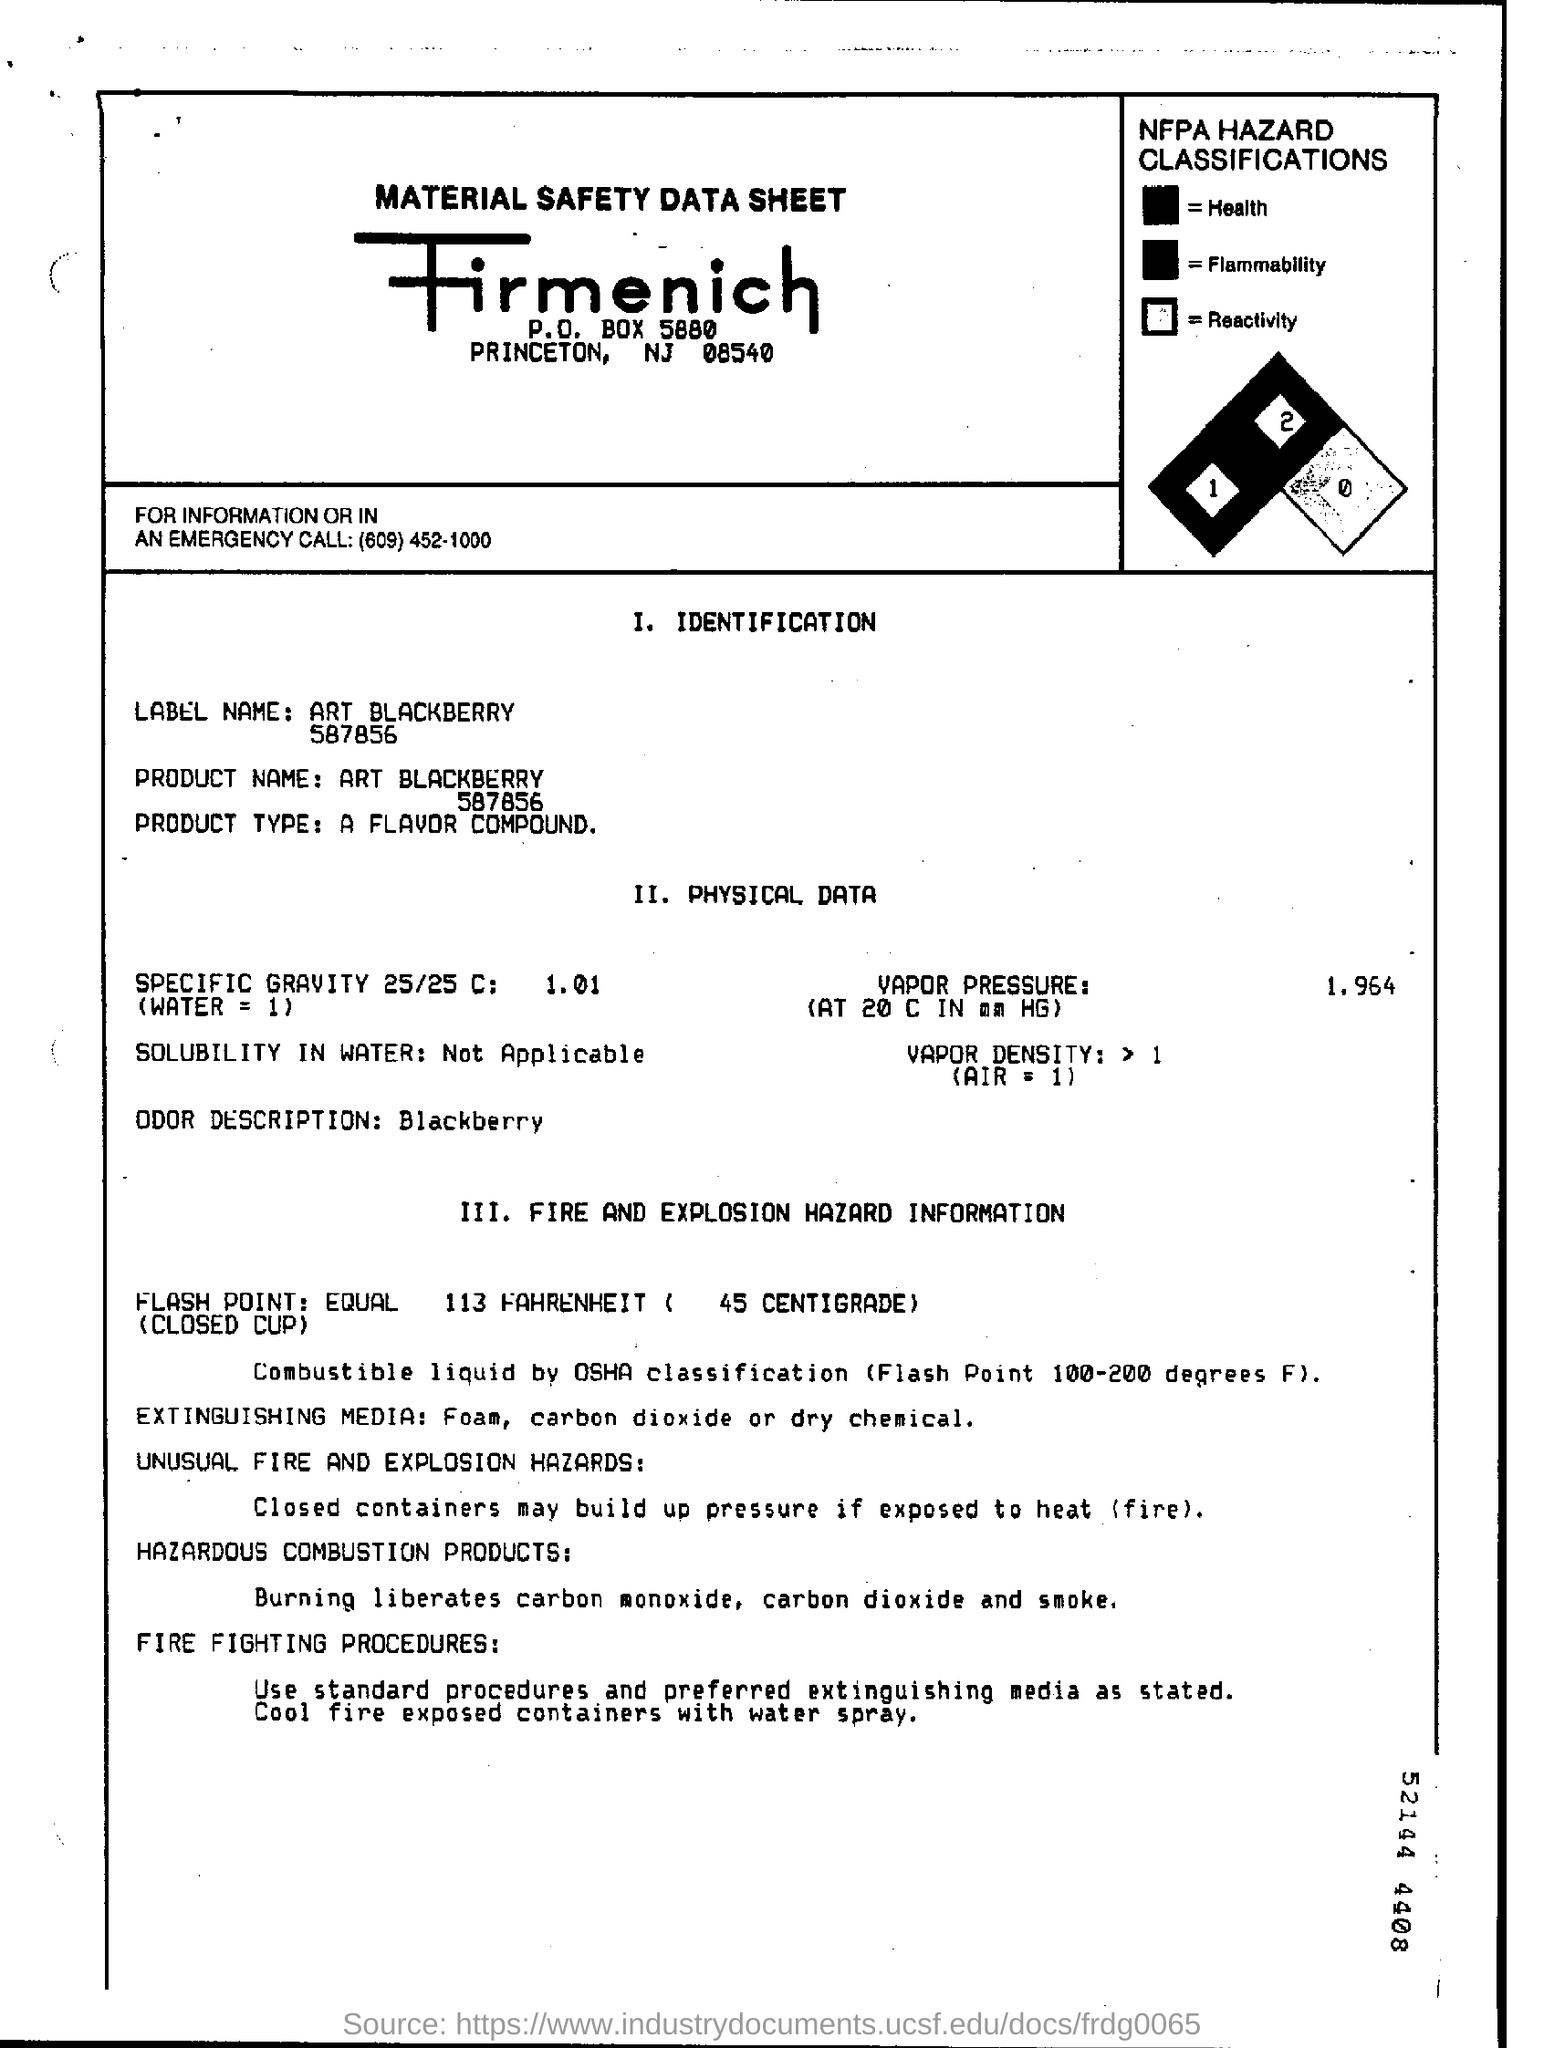What is Vapor Pressure?
Keep it short and to the point. 1.964. 